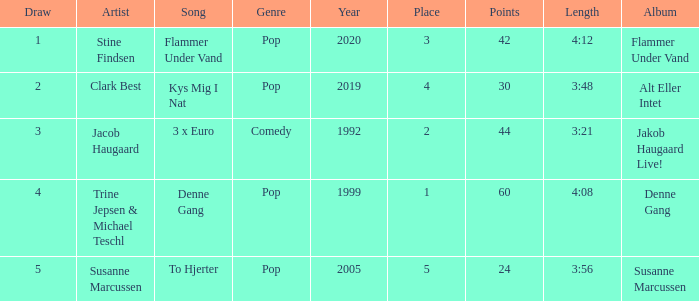What is the Draw that has Points larger than 44 and a Place larger than 1? None. 